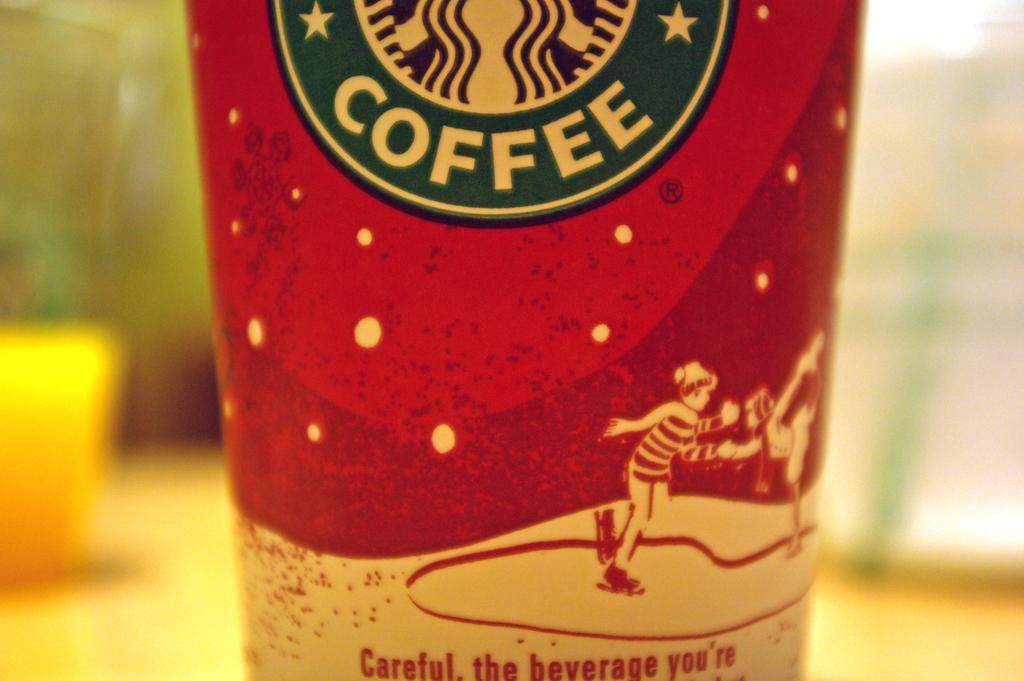<image>
Present a compact description of the photo's key features. A closeup of a Starbucks coffee cup that says "Careful" 